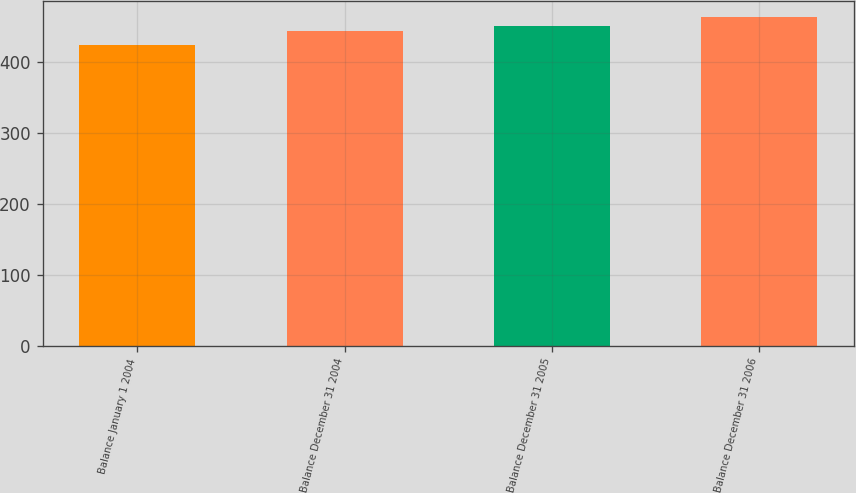Convert chart. <chart><loc_0><loc_0><loc_500><loc_500><bar_chart><fcel>Balance January 1 2004<fcel>Balance December 31 2004<fcel>Balance December 31 2005<fcel>Balance December 31 2006<nl><fcel>425<fcel>445<fcel>452<fcel>464<nl></chart> 